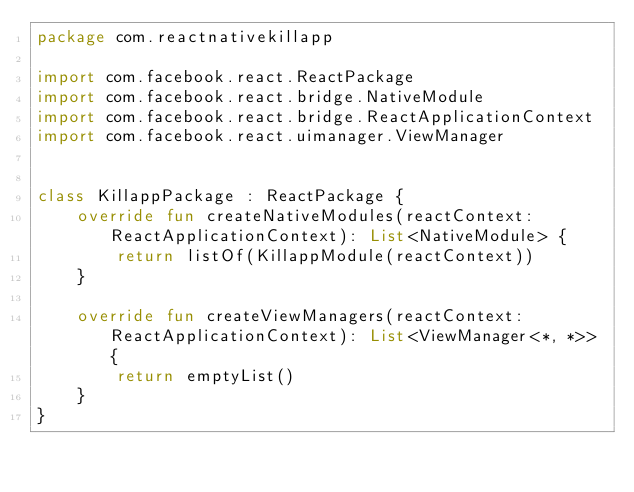<code> <loc_0><loc_0><loc_500><loc_500><_Kotlin_>package com.reactnativekillapp

import com.facebook.react.ReactPackage
import com.facebook.react.bridge.NativeModule
import com.facebook.react.bridge.ReactApplicationContext
import com.facebook.react.uimanager.ViewManager


class KillappPackage : ReactPackage {
    override fun createNativeModules(reactContext: ReactApplicationContext): List<NativeModule> {
        return listOf(KillappModule(reactContext))
    }

    override fun createViewManagers(reactContext: ReactApplicationContext): List<ViewManager<*, *>> {
        return emptyList()
    }
}
</code> 